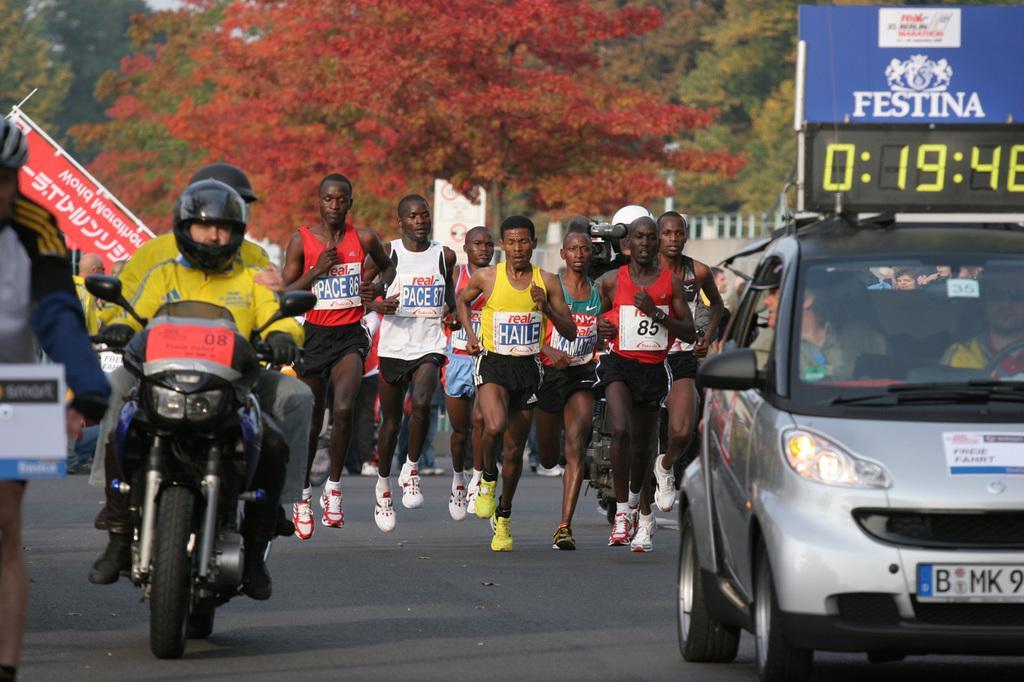Could you give a brief overview of what you see in this image? This picture might be taken from outside of the city and it is sunny. In this image, on the right side, we can see a car which is moving on the road, in the car, we can see two persons. On the left side, we can see a person driving a motorbike, we can also see another person. In the background, we can see a group of people running on the road, hoardings, trees, at the top, we can see a sky, at the bottom, we can see a road. 